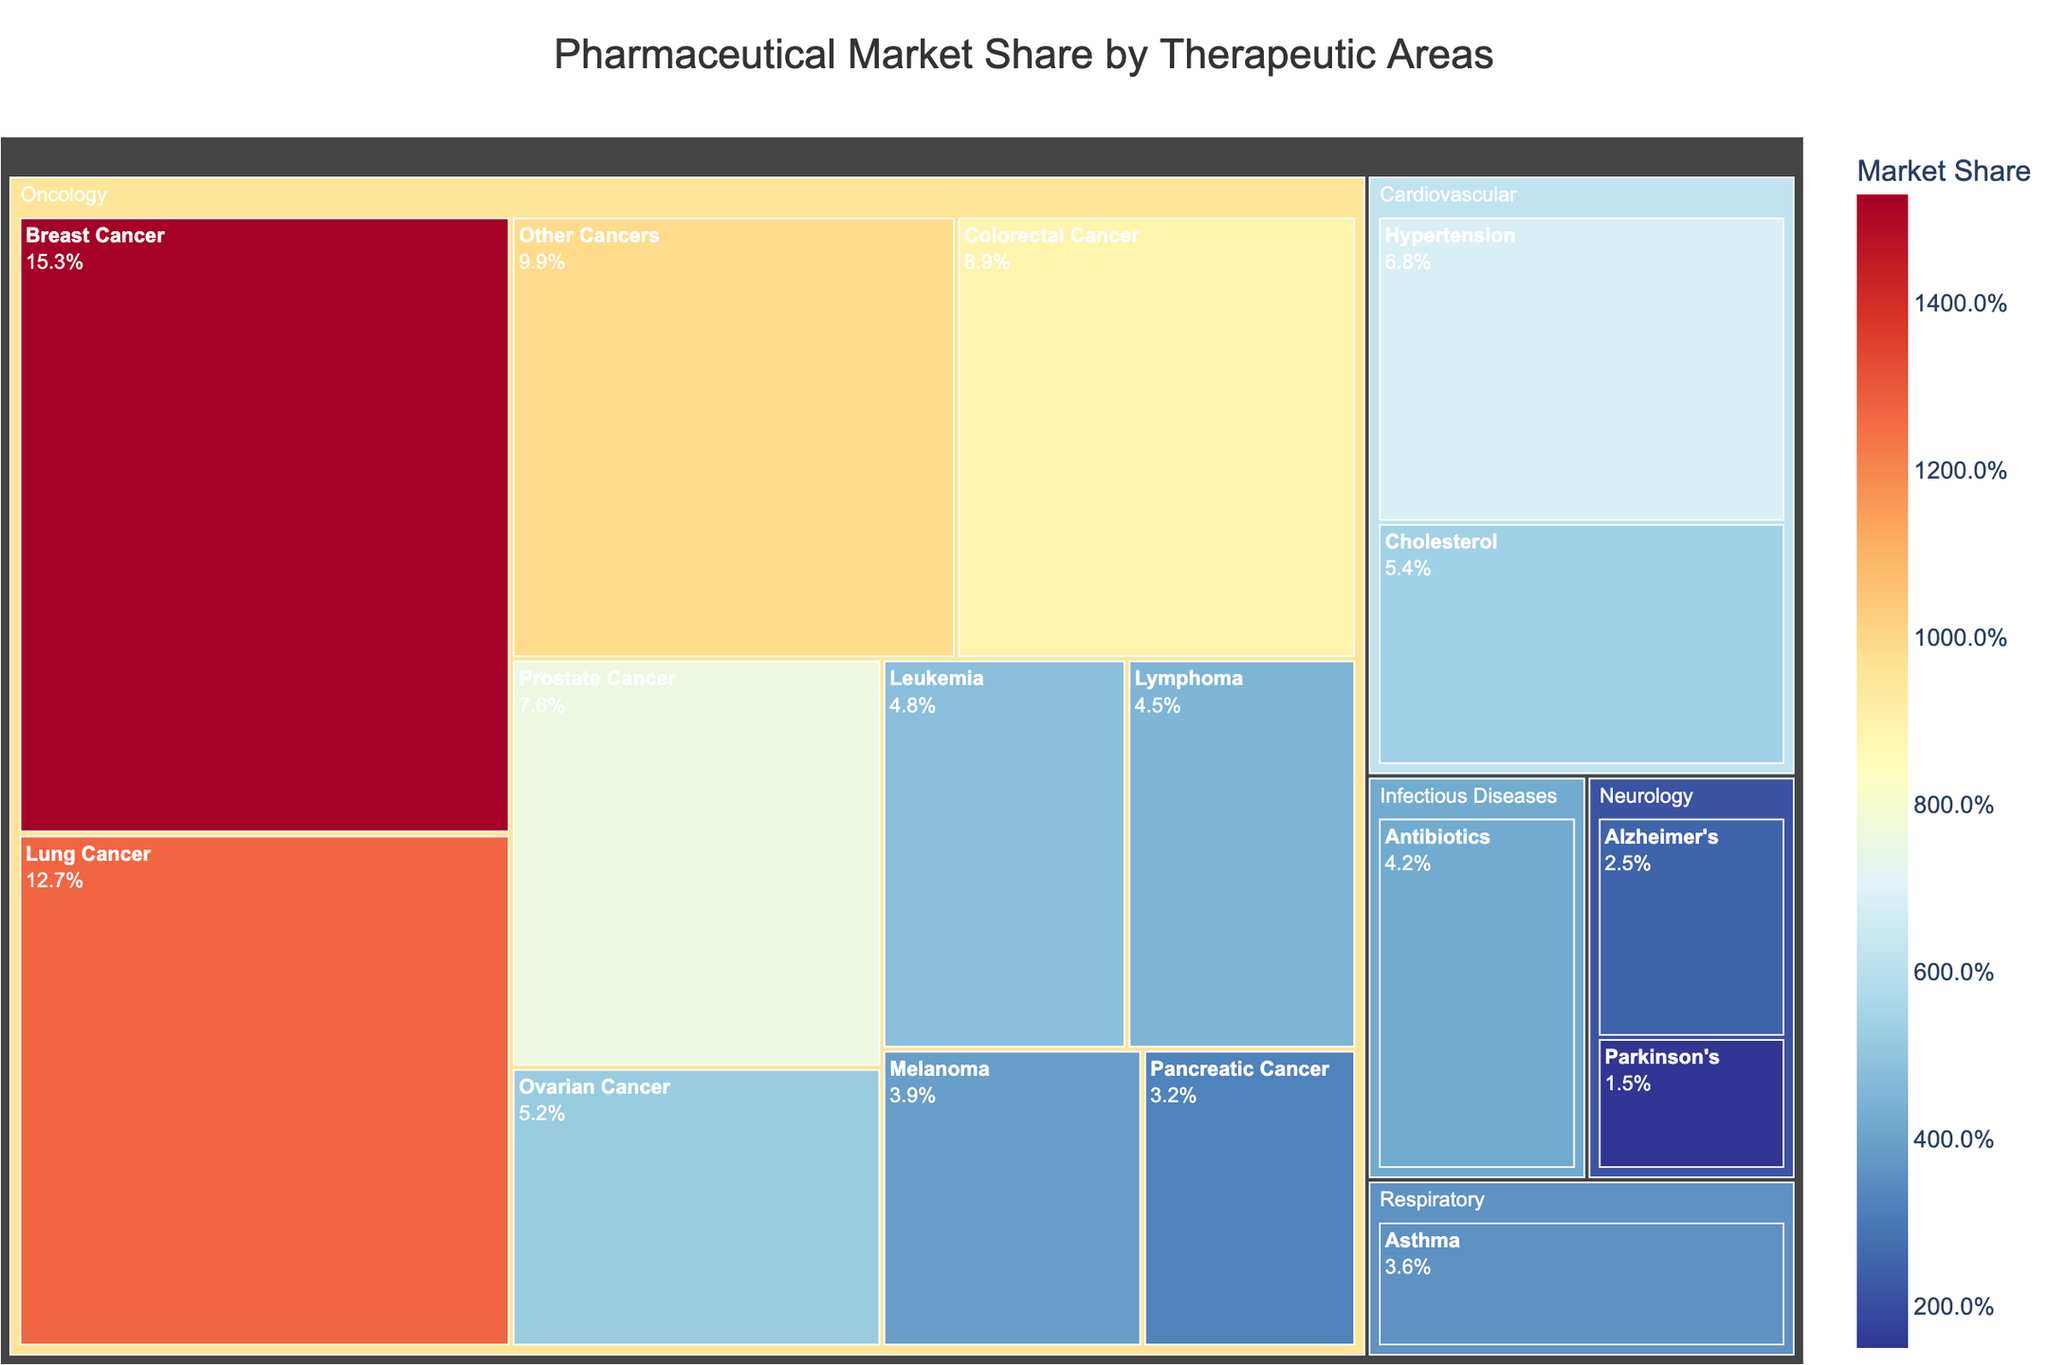What is the title of the treemap? The title is usually found at the top of the figure and provides a summary of what the figure is about. Here, it states the overall theme of the plot.
Answer: Pharmaceutical Market Share by Therapeutic Areas Which subcategory has the largest market share within Oncology? By inspecting the sections under Oncology, look for the one with the highest percentage. Here, the largest section is labeled with the highest value.
Answer: Breast Cancer What's the combined market share of Ovarian Cancer and Lung Cancer within the Oncology category? Add the market shares of Ovarian Cancer (5.2) and Lung Cancer (12.7). The combined value is 5.2% + 12.7% = 17.9%.
Answer: 17.9% How does the market share of Cardiovascular compare to that of Neurology? Summing the market shares of the subcategories under each category: Cardiovascular (Hypertension 6.8% + Cholesterol 5.4% = 12.2%) and Neurology (Alzheimer's 2.5% + Parkinson's 1.5% = 4.0%). Compare these totals.
Answer: Cardiovascular (12.2%) is higher than Neurology (4.0%) Which has a lower market share: Pancreatic Cancer or Leukemia? Identify and compare the market shares of Pancreatic Cancer (3.2%) and Leukemia (4.8%) from the Oncology subcategories. Pancreatic Cancer has the lower share.
Answer: Pancreatic Cancer What is the overall market share for the Oncology category? Sum the market shares of all subcategories within Oncology: 15.3 + 12.7 + 8.9 + 7.6 + 5.2 + 4.8 + 4.5 + 3.9 + 3.2 + 9.9. The total is 75%.
Answer: 75% What is the lowest market share among all subcategories? Identify the lowest percentage among all listed subcategories across all categories, which is Parkinson's at 1.5%.
Answer: Parkinson's Disease Which Cancer type within Oncology has a market share closest to 10%? Look through the Oncology subcategories for a value near 10%. Colorectal Cancer, with 8.9%, is the closest.
Answer: Colorectal Cancer What's the sum of the market shares for the top three subcategories in Oncology? Identify the top three subcategories (Breast Cancer, Lung Cancer, and Colorectal Cancer) and sum their market shares: 15.3 + 12.7 + 8.9. The total is 36.9%.
Answer: 36.9% How does Leukemia compare to Asthma in terms of market share? Both categories are different, but compare Leukemia (4.8%) from Oncology to Asthma (3.6%) from Respiratory by their market shares. Leukemia is higher.
Answer: Leukemia 